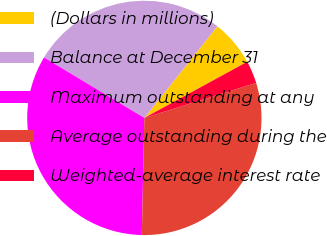<chart> <loc_0><loc_0><loc_500><loc_500><pie_chart><fcel>(Dollars in millions)<fcel>Balance at December 31<fcel>Maximum outstanding at any<fcel>Average outstanding during the<fcel>Weighted-average interest rate<nl><fcel>6.35%<fcel>27.07%<fcel>33.29%<fcel>30.18%<fcel>3.11%<nl></chart> 